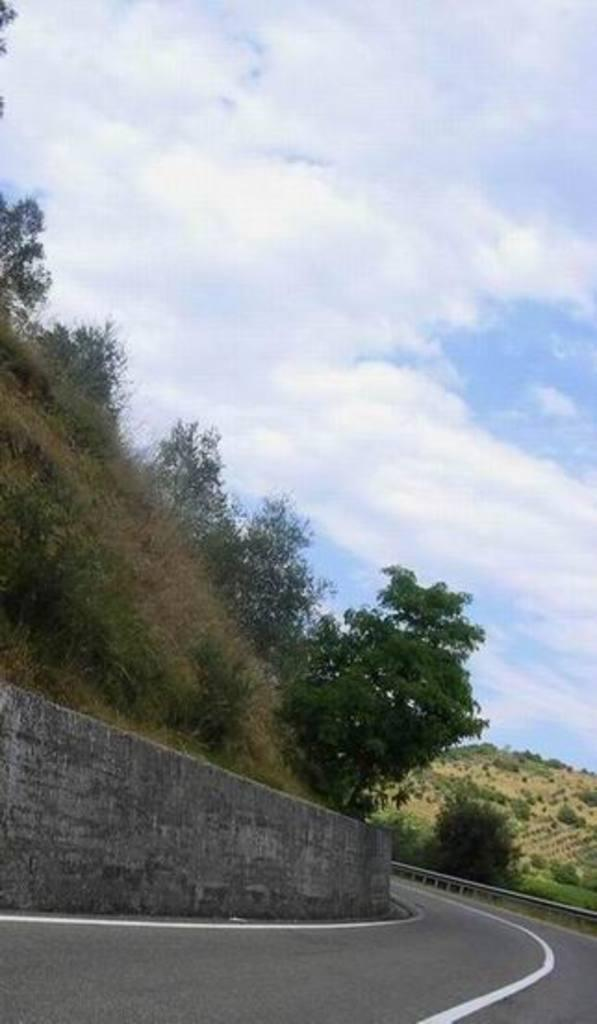What type of pathway is present in the image? There is a road in the image. What structure can be seen alongside the road? There is a wall in the image. What type of vegetation is visible in the image? There are trees visible in the image. What is visible at the top of the image? The sky is visible at the top of the image. What is the condition of the sky in the image? The sky is cloudy in the image. What type of sugar is being used to play the instrument in the image? There is no sugar or instrument present in the image. What route is being taken by the vehicle on the road in the image? There is no vehicle or route mentioned in the image; it only shows a road, a wall, trees, and a cloudy sky. 